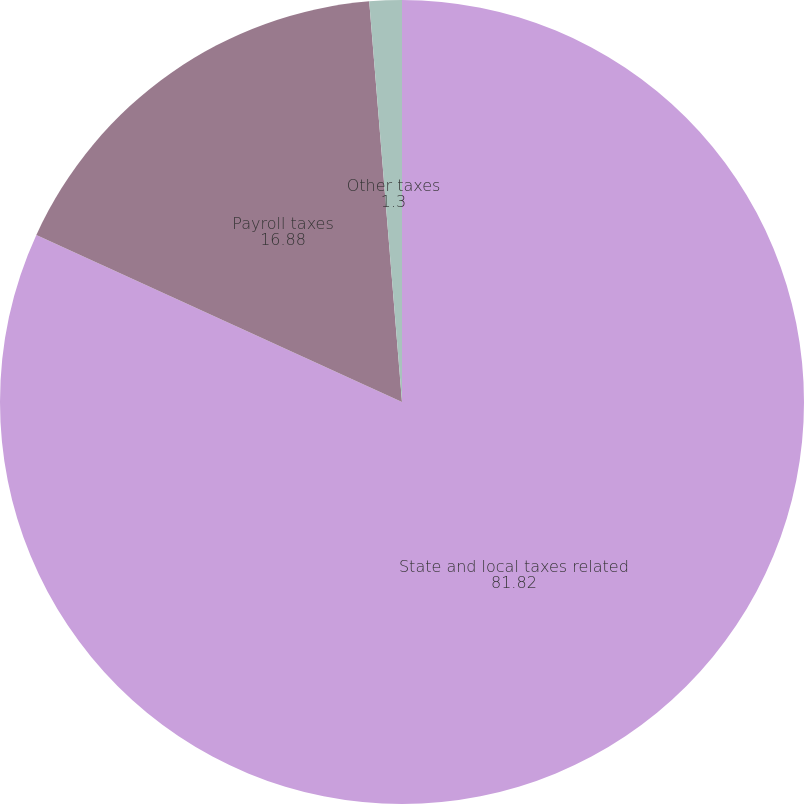Convert chart. <chart><loc_0><loc_0><loc_500><loc_500><pie_chart><fcel>State and local taxes related<fcel>Payroll taxes<fcel>Other taxes<nl><fcel>81.82%<fcel>16.88%<fcel>1.3%<nl></chart> 